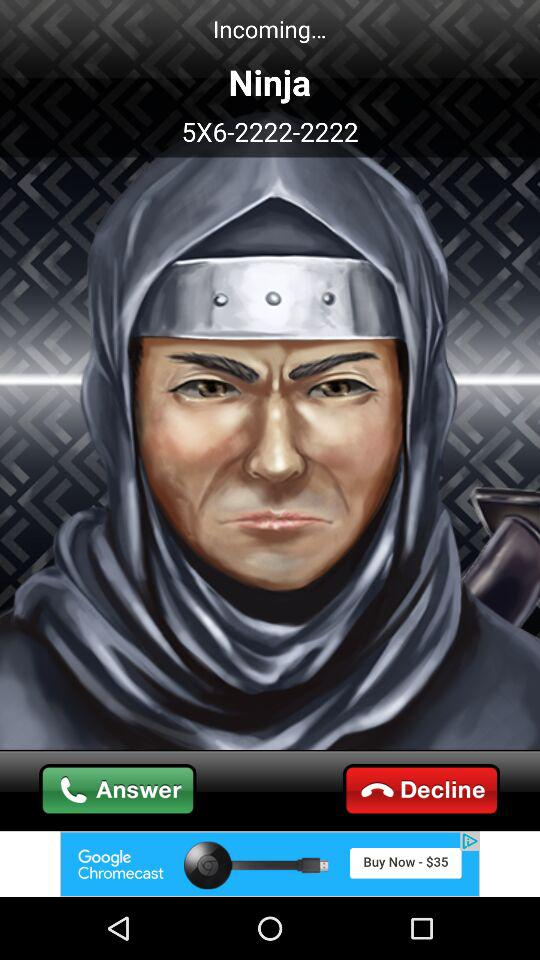What is the caller's name? The caller's name is Ninja. 